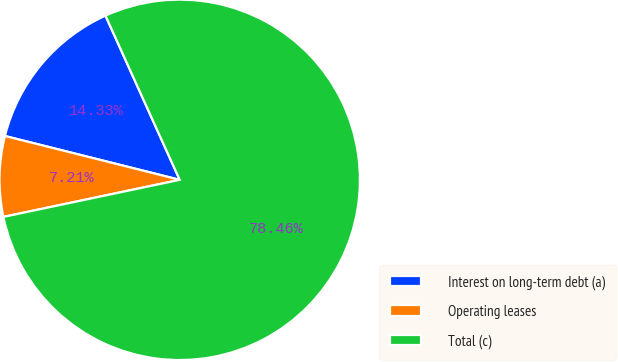<chart> <loc_0><loc_0><loc_500><loc_500><pie_chart><fcel>Interest on long-term debt (a)<fcel>Operating leases<fcel>Total (c)<nl><fcel>14.33%<fcel>7.21%<fcel>78.46%<nl></chart> 